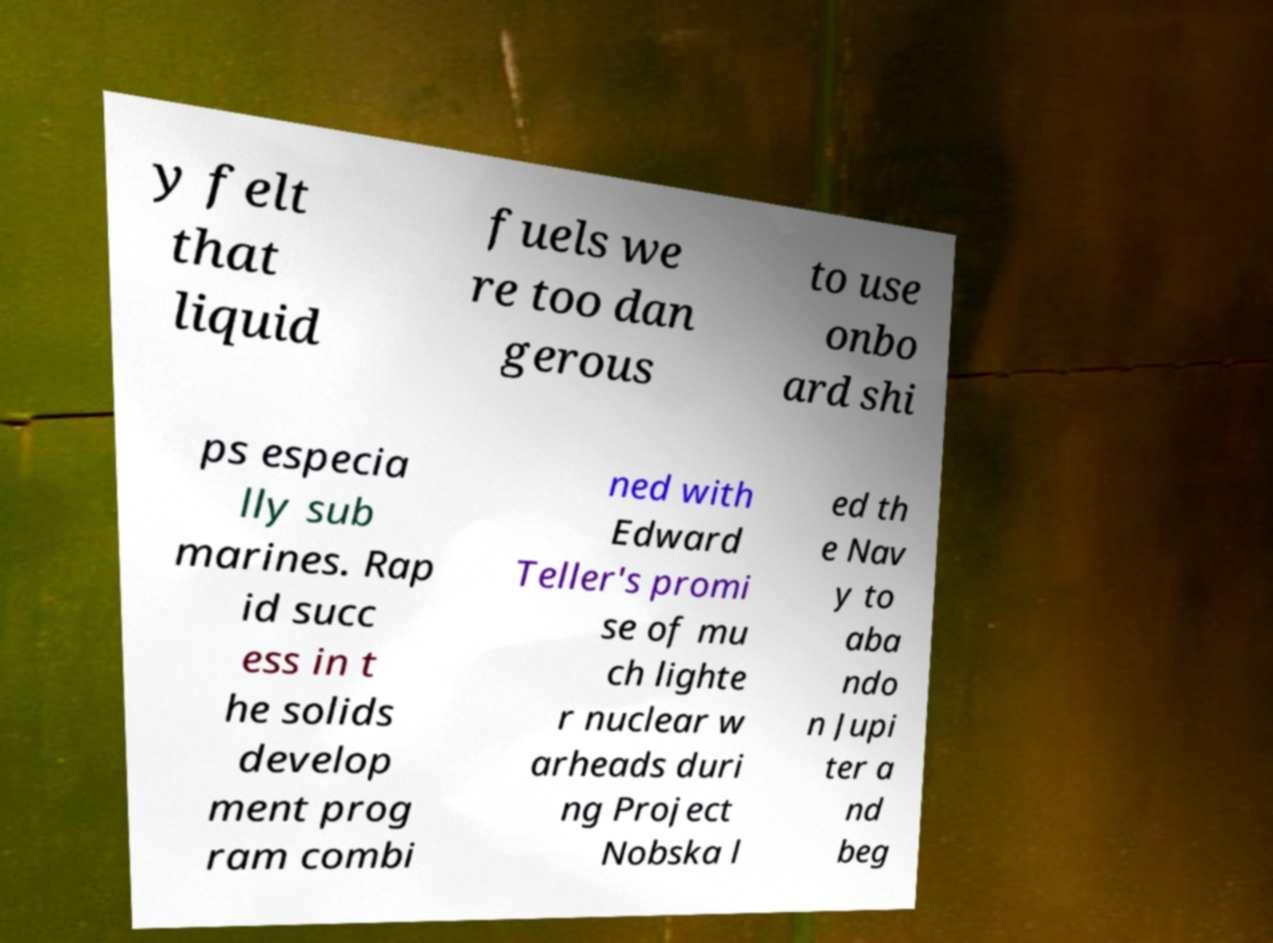There's text embedded in this image that I need extracted. Can you transcribe it verbatim? y felt that liquid fuels we re too dan gerous to use onbo ard shi ps especia lly sub marines. Rap id succ ess in t he solids develop ment prog ram combi ned with Edward Teller's promi se of mu ch lighte r nuclear w arheads duri ng Project Nobska l ed th e Nav y to aba ndo n Jupi ter a nd beg 